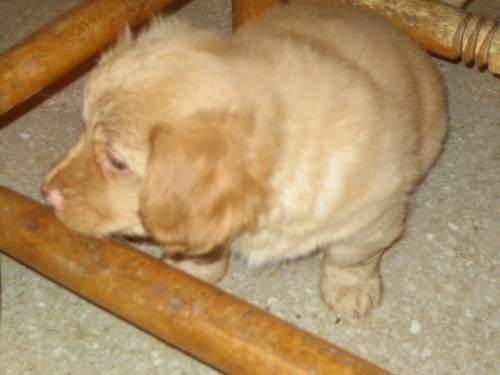What mood or feeling does the image evoke? The image evokes a sense of innocence and curiosity often associated with puppies. The stance of the puppy suggests it is in the middle of exploring, which adds to the feeling of gentle playfulness and the everyday joy that pets can bring into a home. 